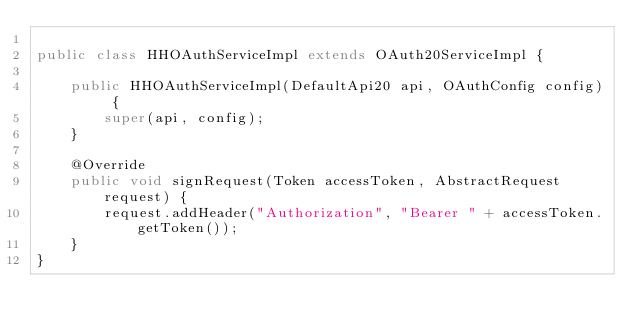Convert code to text. <code><loc_0><loc_0><loc_500><loc_500><_Java_>
public class HHOAuthServiceImpl extends OAuth20ServiceImpl {

    public HHOAuthServiceImpl(DefaultApi20 api, OAuthConfig config) {
        super(api, config);
    }

    @Override
    public void signRequest(Token accessToken, AbstractRequest request) {
        request.addHeader("Authorization", "Bearer " + accessToken.getToken());
    }
}
</code> 